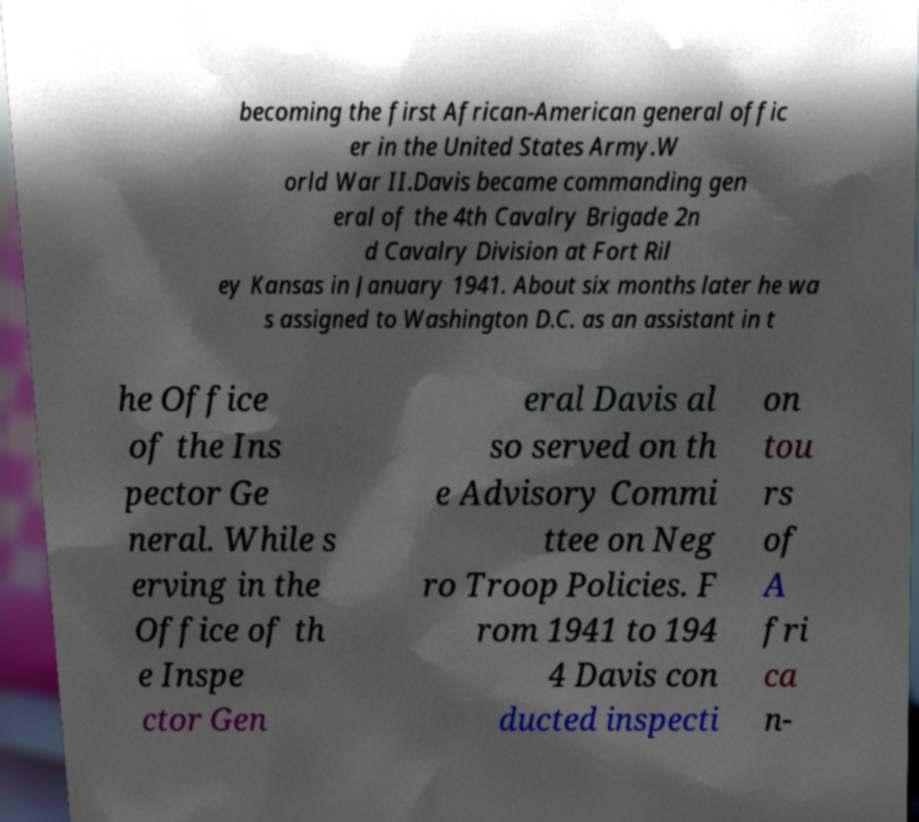Can you accurately transcribe the text from the provided image for me? becoming the first African-American general offic er in the United States Army.W orld War II.Davis became commanding gen eral of the 4th Cavalry Brigade 2n d Cavalry Division at Fort Ril ey Kansas in January 1941. About six months later he wa s assigned to Washington D.C. as an assistant in t he Office of the Ins pector Ge neral. While s erving in the Office of th e Inspe ctor Gen eral Davis al so served on th e Advisory Commi ttee on Neg ro Troop Policies. F rom 1941 to 194 4 Davis con ducted inspecti on tou rs of A fri ca n- 